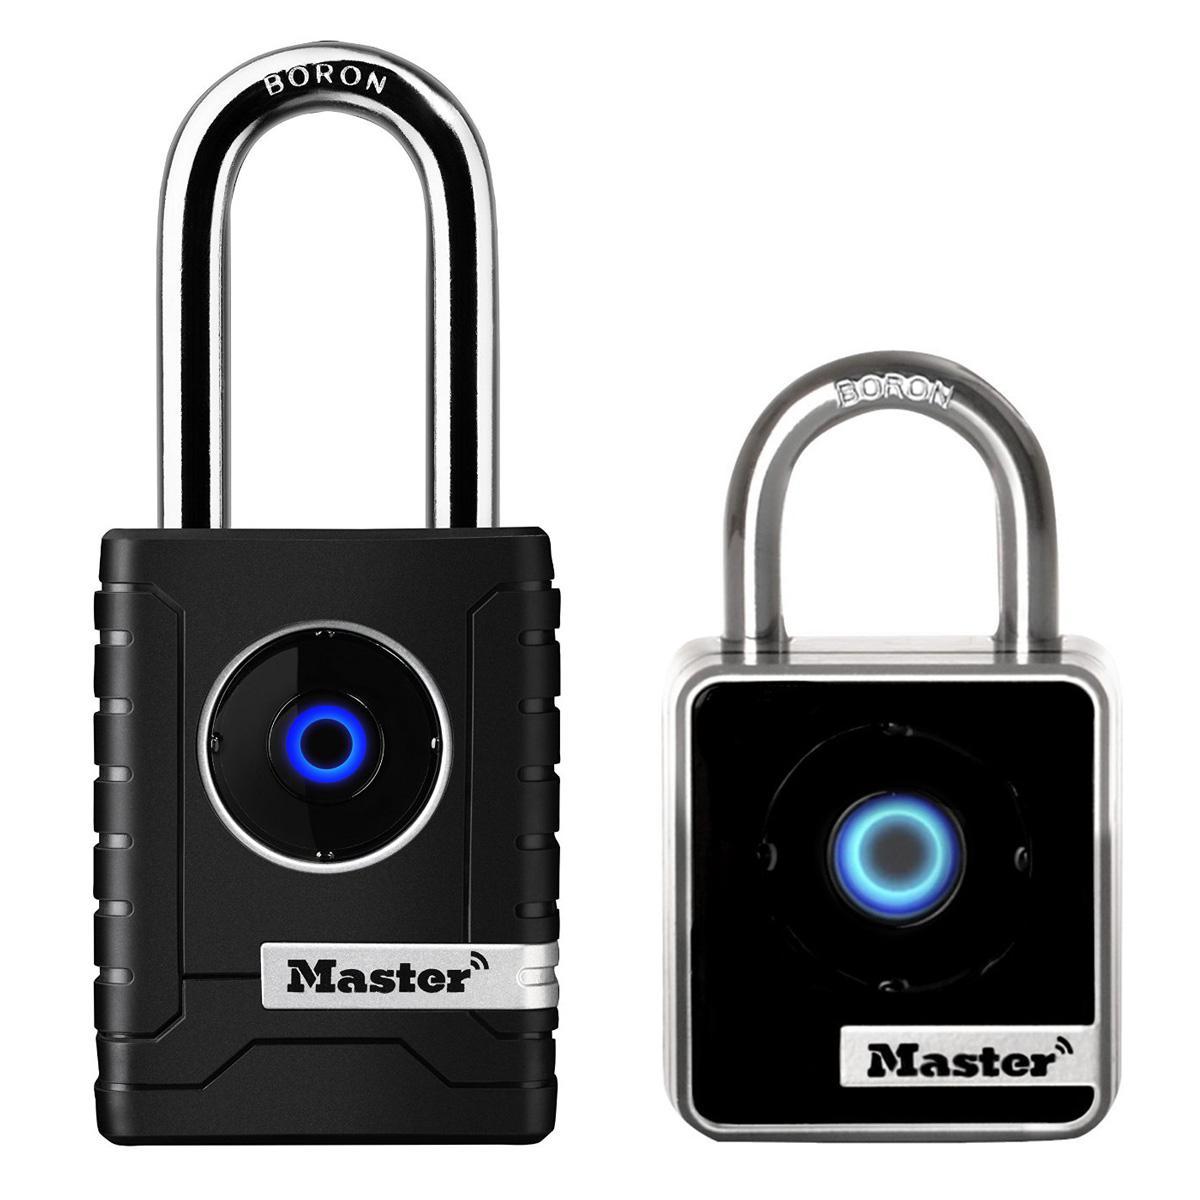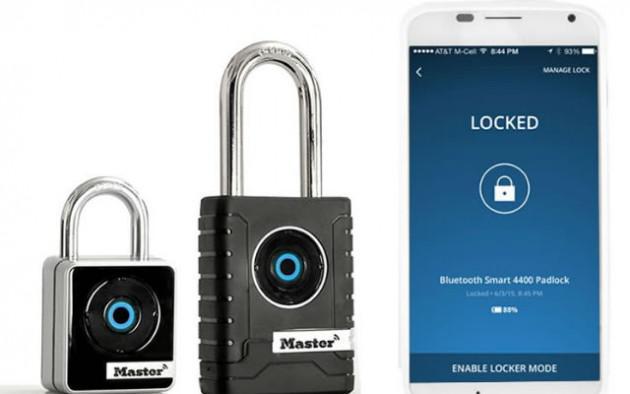The first image is the image on the left, the second image is the image on the right. Examine the images to the left and right. Is the description "There are two locks." accurate? Answer yes or no. No. The first image is the image on the left, the second image is the image on the right. Assess this claim about the two images: "There are at least three padlocks.". Correct or not? Answer yes or no. Yes. 